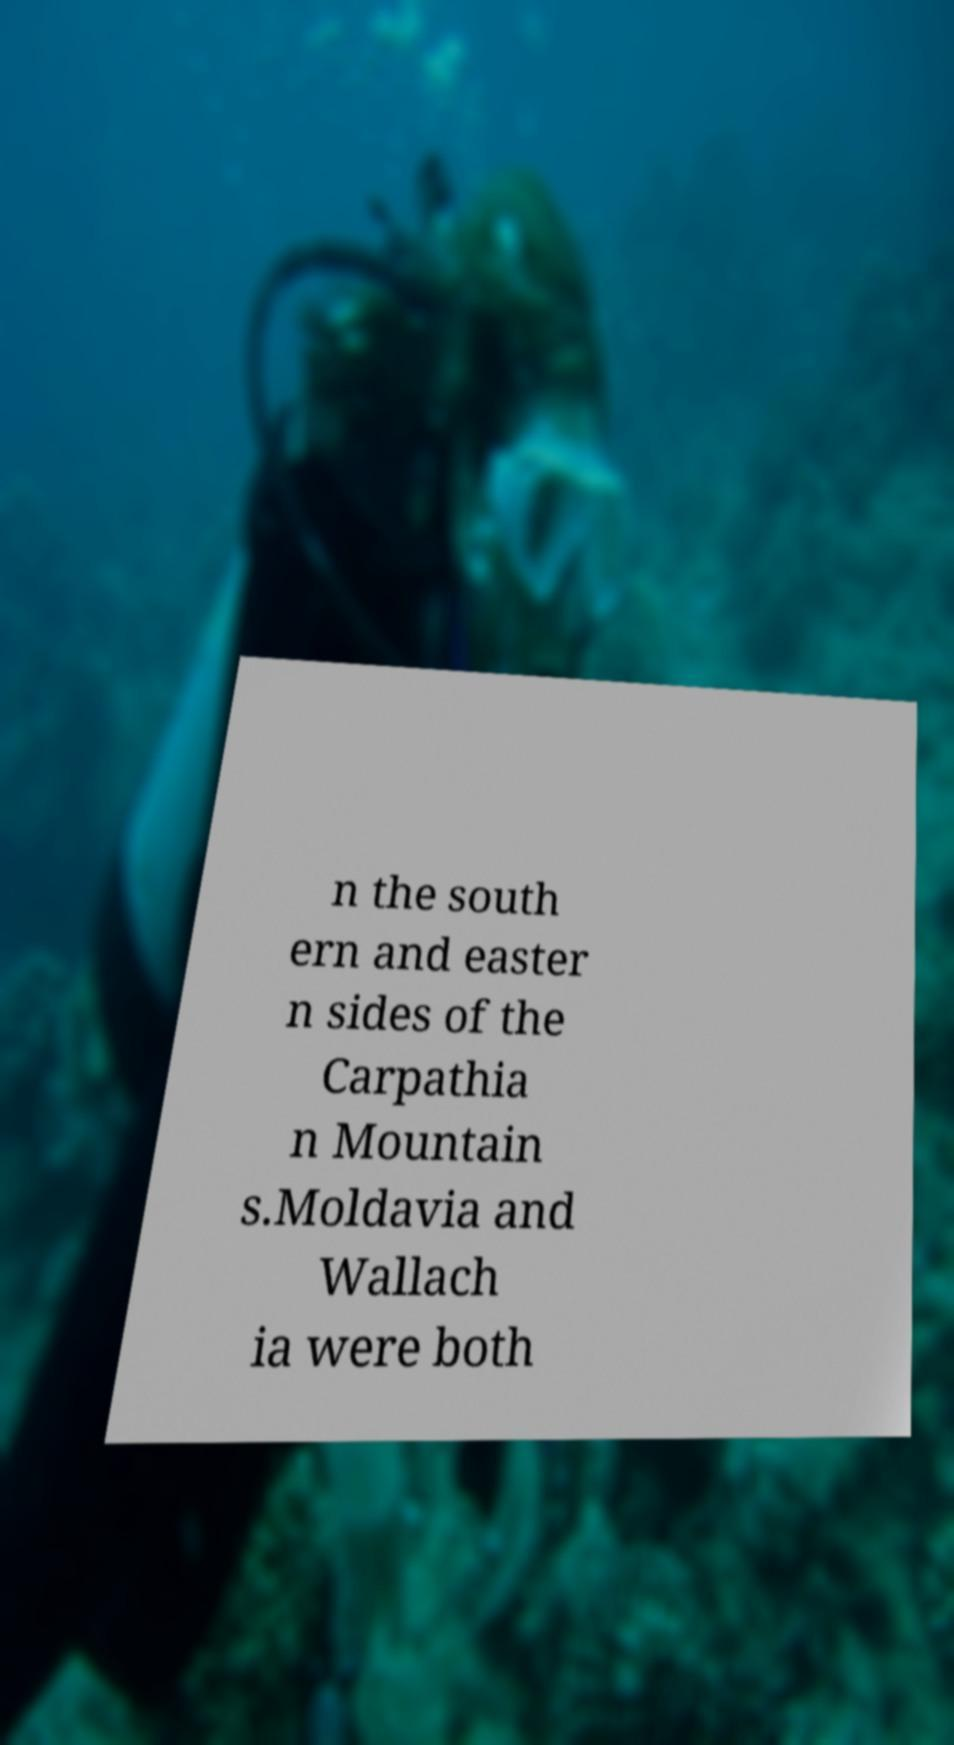Please identify and transcribe the text found in this image. n the south ern and easter n sides of the Carpathia n Mountain s.Moldavia and Wallach ia were both 